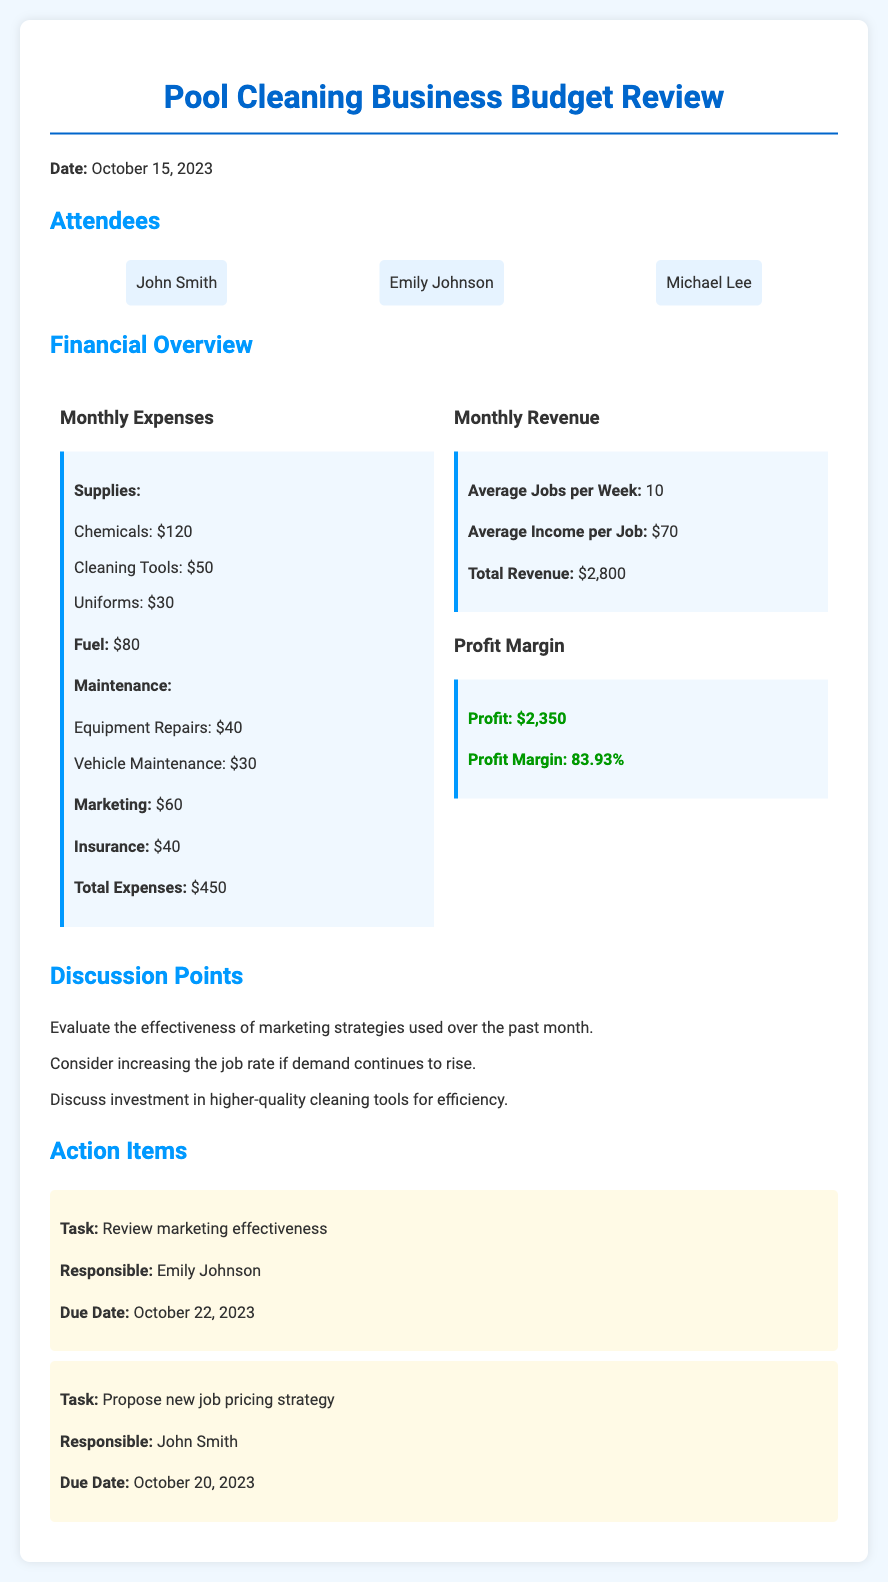what is the date of the budget review? The date of the budget review is explicitly stated in the document as October 15, 2023.
Answer: October 15, 2023 who is responsible for reviewing marketing effectiveness? The document specifies that Emily Johnson is responsible for reviewing marketing effectiveness.
Answer: Emily Johnson what are total monthly expenses? The total monthly expenses are summarized in the financial overview, which shows a total of $450.
Answer: $450 what is the average income per job? The average income per job is mentioned in the monthly revenue section as $70.
Answer: $70 how many average jobs are performed per week? The average jobs per week are stated as 10 in the monthly revenue section of the document.
Answer: 10 what is the profit margin percentage? The document provides the profit margin percentage, which is calculated as 83.93%.
Answer: 83.93% which attendee is responsible for proposing a new job pricing strategy? The document lists John Smith as the person responsible for proposing a new job pricing strategy.
Answer: John Smith what is the total revenue for the month? The total revenue is directly mentioned in the financial overview as $2,800.
Answer: $2,800 what is one of the discussion points mentioned in the meeting? The document outlines several discussion points, including evaluating the effectiveness of marketing strategies used over the past month.
Answer: Evaluate the effectiveness of marketing strategies used over the past month 